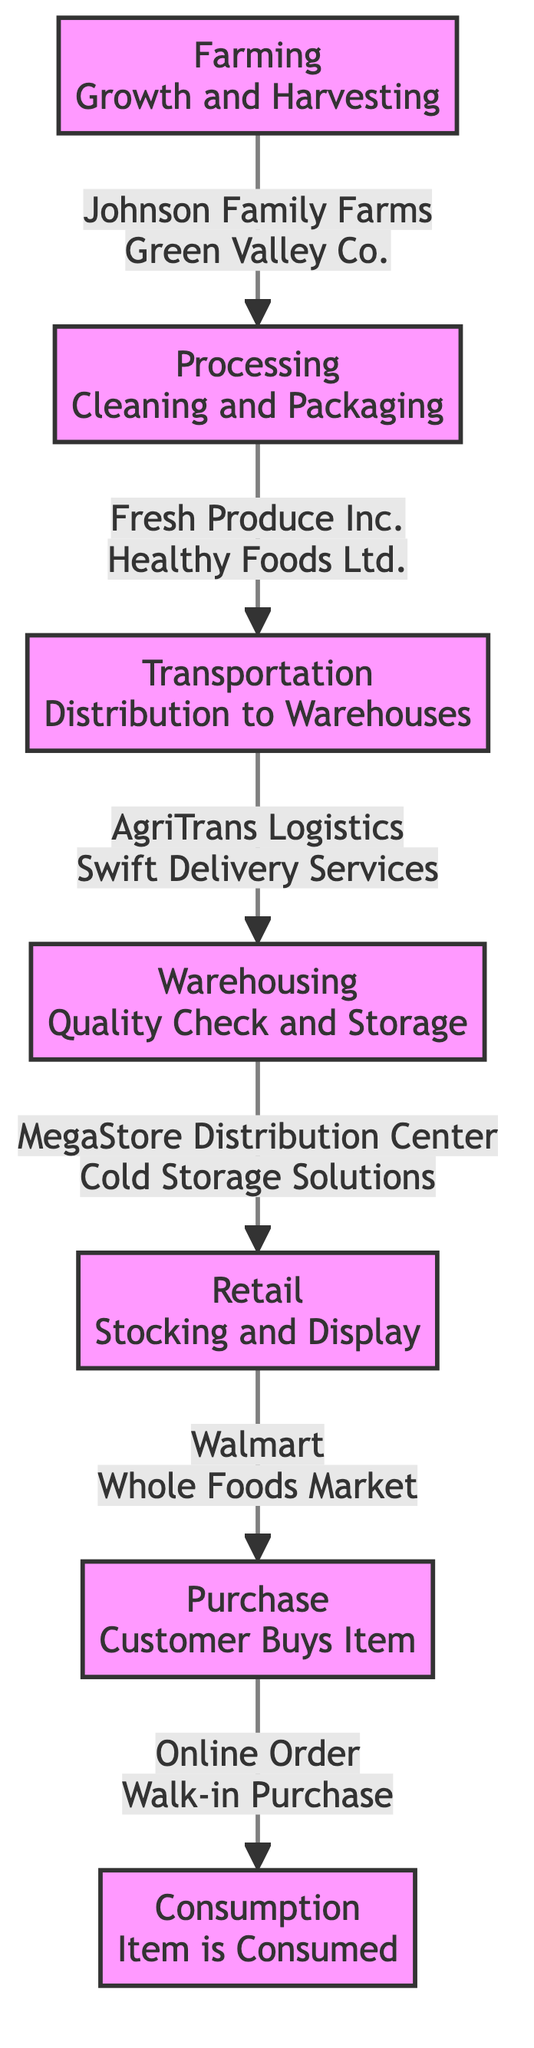What is the first step in the supply chain? The diagram shows that the first node is "Farming Growth and Harvesting," indicating this is where the supply chain begins.
Answer: Farming Growth and Harvesting How many nodes are present in the diagram? There are a total of seven nodes in the diagram, each representing a different stage in the journey of a grocery item.
Answer: 7 Which company is associated with the processing stage? The processing stage is linked to "Fresh Produce Inc." and "Healthy Foods Ltd." as the companies involved in this step.
Answer: Fresh Produce Inc., Healthy Foods Ltd What relationship exists between transportation and warehousing? The diagram indicates an arrow flowing from "Transportation Distribution to Warehouses" to "Warehousing Quality Check and Storage," showing that transportation leads directly to warehousing.
Answer: Transportation leads to Warehousing What stage comes immediately after the purchase? The stage that follows "Purchase Customer Buys Item" is "Consumption Item is Consumed," according to the flow of the diagram.
Answer: Consumption Item is Consumed Which company is linked to the retail stage? "Walmart" and "Whole Foods Market" are the companies associated with the retail stage, as per the information displayed in the diagram.
Answer: Walmart, Whole Foods Market How many edges are there connecting the nodes? The diagram features six edges, each representing the flow from one stage to the next in the supply chain process.
Answer: 6 What is the final step in the supply chain? The last node in the sequence is "Consumption Item is Consumed," marking the end of the supply chain journey for the grocery item.
Answer: Consumption Item is Consumed What is the common theme of companies in the processing step? The theme is health and freshness, as both companies listed in the processing step, "Fresh Produce Inc." and "Healthy Foods Ltd." focus on providing healthy processed food options.
Answer: Health and Freshness 